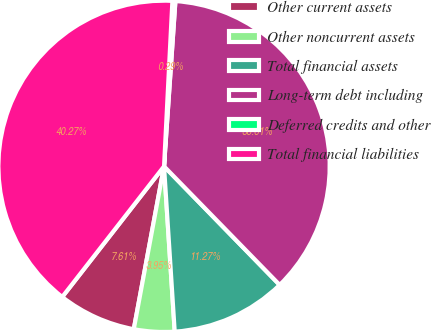Convert chart. <chart><loc_0><loc_0><loc_500><loc_500><pie_chart><fcel>Other current assets<fcel>Other noncurrent assets<fcel>Total financial assets<fcel>Long-term debt including<fcel>Deferred credits and other<fcel>Total financial liabilities<nl><fcel>7.61%<fcel>3.95%<fcel>11.27%<fcel>36.6%<fcel>0.29%<fcel>40.26%<nl></chart> 